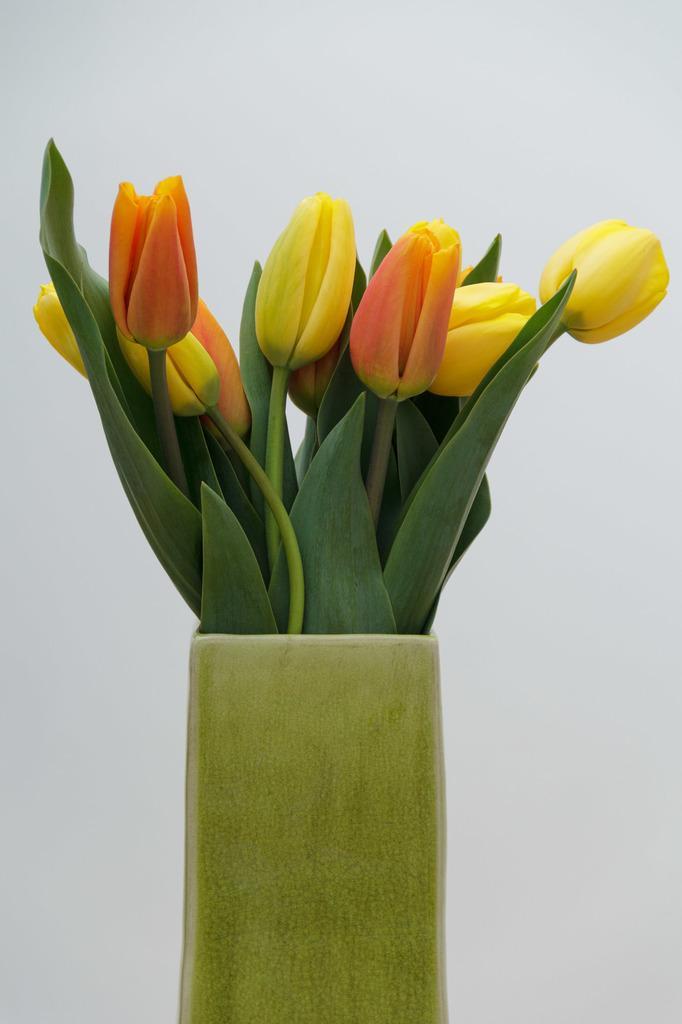How would you summarize this image in a sentence or two? In this image in front there is a flower pot. On the backside there is a wall. 